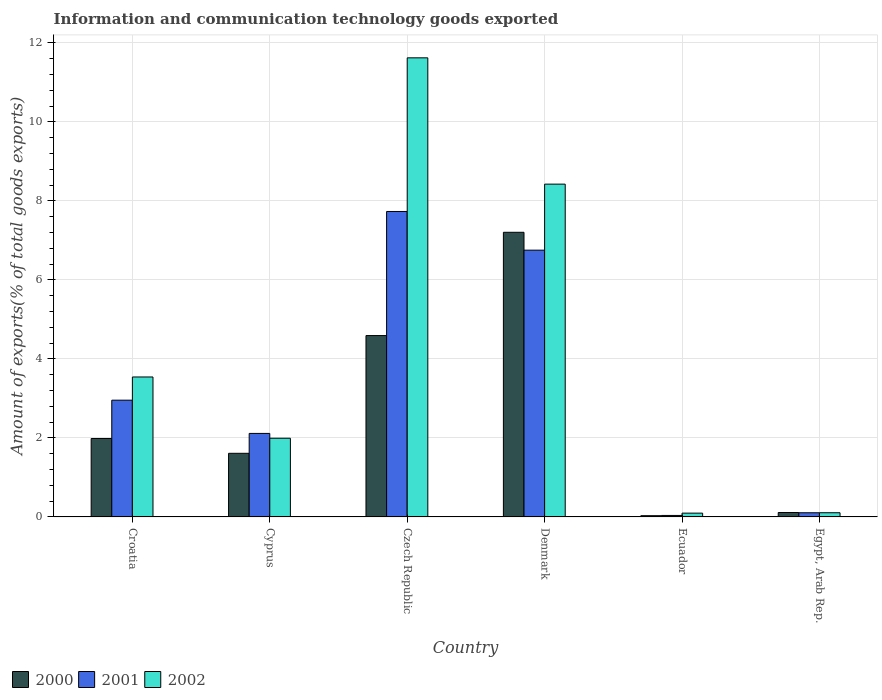How many groups of bars are there?
Offer a terse response. 6. How many bars are there on the 4th tick from the left?
Give a very brief answer. 3. What is the label of the 3rd group of bars from the left?
Ensure brevity in your answer.  Czech Republic. In how many cases, is the number of bars for a given country not equal to the number of legend labels?
Your answer should be compact. 0. What is the amount of goods exported in 2001 in Czech Republic?
Provide a succinct answer. 7.73. Across all countries, what is the maximum amount of goods exported in 2001?
Offer a terse response. 7.73. Across all countries, what is the minimum amount of goods exported in 2000?
Your response must be concise. 0.03. In which country was the amount of goods exported in 2001 maximum?
Keep it short and to the point. Czech Republic. In which country was the amount of goods exported in 2001 minimum?
Your response must be concise. Ecuador. What is the total amount of goods exported in 2001 in the graph?
Provide a succinct answer. 19.7. What is the difference between the amount of goods exported in 2002 in Czech Republic and that in Denmark?
Your answer should be very brief. 3.2. What is the difference between the amount of goods exported in 2002 in Croatia and the amount of goods exported in 2001 in Egypt, Arab Rep.?
Keep it short and to the point. 3.44. What is the average amount of goods exported in 2000 per country?
Offer a terse response. 2.59. What is the difference between the amount of goods exported of/in 2001 and amount of goods exported of/in 2002 in Denmark?
Provide a succinct answer. -1.67. What is the ratio of the amount of goods exported in 2001 in Denmark to that in Egypt, Arab Rep.?
Make the answer very short. 63.88. What is the difference between the highest and the second highest amount of goods exported in 2000?
Provide a short and direct response. -2.61. What is the difference between the highest and the lowest amount of goods exported in 2002?
Provide a short and direct response. 11.53. What does the 2nd bar from the left in Czech Republic represents?
Offer a terse response. 2001. How many countries are there in the graph?
Offer a very short reply. 6. What is the difference between two consecutive major ticks on the Y-axis?
Offer a terse response. 2. Are the values on the major ticks of Y-axis written in scientific E-notation?
Give a very brief answer. No. Does the graph contain any zero values?
Keep it short and to the point. No. Does the graph contain grids?
Provide a short and direct response. Yes. Where does the legend appear in the graph?
Make the answer very short. Bottom left. What is the title of the graph?
Keep it short and to the point. Information and communication technology goods exported. Does "1981" appear as one of the legend labels in the graph?
Your response must be concise. No. What is the label or title of the Y-axis?
Offer a very short reply. Amount of exports(% of total goods exports). What is the Amount of exports(% of total goods exports) in 2000 in Croatia?
Keep it short and to the point. 1.99. What is the Amount of exports(% of total goods exports) of 2001 in Croatia?
Keep it short and to the point. 2.96. What is the Amount of exports(% of total goods exports) in 2002 in Croatia?
Provide a short and direct response. 3.54. What is the Amount of exports(% of total goods exports) in 2000 in Cyprus?
Your answer should be compact. 1.61. What is the Amount of exports(% of total goods exports) in 2001 in Cyprus?
Your response must be concise. 2.11. What is the Amount of exports(% of total goods exports) of 2002 in Cyprus?
Provide a short and direct response. 1.99. What is the Amount of exports(% of total goods exports) of 2000 in Czech Republic?
Offer a terse response. 4.59. What is the Amount of exports(% of total goods exports) of 2001 in Czech Republic?
Offer a terse response. 7.73. What is the Amount of exports(% of total goods exports) of 2002 in Czech Republic?
Your answer should be very brief. 11.62. What is the Amount of exports(% of total goods exports) of 2000 in Denmark?
Offer a very short reply. 7.21. What is the Amount of exports(% of total goods exports) in 2001 in Denmark?
Offer a very short reply. 6.75. What is the Amount of exports(% of total goods exports) of 2002 in Denmark?
Your answer should be compact. 8.43. What is the Amount of exports(% of total goods exports) of 2000 in Ecuador?
Provide a succinct answer. 0.03. What is the Amount of exports(% of total goods exports) of 2001 in Ecuador?
Your answer should be very brief. 0.04. What is the Amount of exports(% of total goods exports) in 2002 in Ecuador?
Keep it short and to the point. 0.1. What is the Amount of exports(% of total goods exports) in 2000 in Egypt, Arab Rep.?
Keep it short and to the point. 0.11. What is the Amount of exports(% of total goods exports) of 2001 in Egypt, Arab Rep.?
Keep it short and to the point. 0.11. What is the Amount of exports(% of total goods exports) in 2002 in Egypt, Arab Rep.?
Your answer should be compact. 0.11. Across all countries, what is the maximum Amount of exports(% of total goods exports) of 2000?
Ensure brevity in your answer.  7.21. Across all countries, what is the maximum Amount of exports(% of total goods exports) of 2001?
Give a very brief answer. 7.73. Across all countries, what is the maximum Amount of exports(% of total goods exports) of 2002?
Your answer should be compact. 11.62. Across all countries, what is the minimum Amount of exports(% of total goods exports) in 2000?
Provide a succinct answer. 0.03. Across all countries, what is the minimum Amount of exports(% of total goods exports) in 2001?
Keep it short and to the point. 0.04. Across all countries, what is the minimum Amount of exports(% of total goods exports) of 2002?
Your answer should be very brief. 0.1. What is the total Amount of exports(% of total goods exports) in 2000 in the graph?
Ensure brevity in your answer.  15.54. What is the total Amount of exports(% of total goods exports) in 2001 in the graph?
Offer a very short reply. 19.7. What is the total Amount of exports(% of total goods exports) in 2002 in the graph?
Your response must be concise. 25.79. What is the difference between the Amount of exports(% of total goods exports) in 2000 in Croatia and that in Cyprus?
Offer a terse response. 0.38. What is the difference between the Amount of exports(% of total goods exports) of 2001 in Croatia and that in Cyprus?
Provide a short and direct response. 0.84. What is the difference between the Amount of exports(% of total goods exports) of 2002 in Croatia and that in Cyprus?
Give a very brief answer. 1.55. What is the difference between the Amount of exports(% of total goods exports) of 2000 in Croatia and that in Czech Republic?
Your answer should be very brief. -2.61. What is the difference between the Amount of exports(% of total goods exports) of 2001 in Croatia and that in Czech Republic?
Keep it short and to the point. -4.78. What is the difference between the Amount of exports(% of total goods exports) of 2002 in Croatia and that in Czech Republic?
Provide a succinct answer. -8.08. What is the difference between the Amount of exports(% of total goods exports) of 2000 in Croatia and that in Denmark?
Your answer should be very brief. -5.22. What is the difference between the Amount of exports(% of total goods exports) in 2001 in Croatia and that in Denmark?
Your answer should be very brief. -3.8. What is the difference between the Amount of exports(% of total goods exports) in 2002 in Croatia and that in Denmark?
Ensure brevity in your answer.  -4.88. What is the difference between the Amount of exports(% of total goods exports) of 2000 in Croatia and that in Ecuador?
Provide a short and direct response. 1.95. What is the difference between the Amount of exports(% of total goods exports) in 2001 in Croatia and that in Ecuador?
Make the answer very short. 2.92. What is the difference between the Amount of exports(% of total goods exports) in 2002 in Croatia and that in Ecuador?
Your response must be concise. 3.45. What is the difference between the Amount of exports(% of total goods exports) in 2000 in Croatia and that in Egypt, Arab Rep.?
Give a very brief answer. 1.87. What is the difference between the Amount of exports(% of total goods exports) of 2001 in Croatia and that in Egypt, Arab Rep.?
Offer a very short reply. 2.85. What is the difference between the Amount of exports(% of total goods exports) of 2002 in Croatia and that in Egypt, Arab Rep.?
Offer a terse response. 3.44. What is the difference between the Amount of exports(% of total goods exports) of 2000 in Cyprus and that in Czech Republic?
Keep it short and to the point. -2.98. What is the difference between the Amount of exports(% of total goods exports) of 2001 in Cyprus and that in Czech Republic?
Give a very brief answer. -5.62. What is the difference between the Amount of exports(% of total goods exports) in 2002 in Cyprus and that in Czech Republic?
Provide a short and direct response. -9.63. What is the difference between the Amount of exports(% of total goods exports) of 2000 in Cyprus and that in Denmark?
Make the answer very short. -5.6. What is the difference between the Amount of exports(% of total goods exports) of 2001 in Cyprus and that in Denmark?
Make the answer very short. -4.64. What is the difference between the Amount of exports(% of total goods exports) in 2002 in Cyprus and that in Denmark?
Provide a short and direct response. -6.43. What is the difference between the Amount of exports(% of total goods exports) of 2000 in Cyprus and that in Ecuador?
Your answer should be very brief. 1.58. What is the difference between the Amount of exports(% of total goods exports) of 2001 in Cyprus and that in Ecuador?
Your response must be concise. 2.08. What is the difference between the Amount of exports(% of total goods exports) of 2002 in Cyprus and that in Ecuador?
Ensure brevity in your answer.  1.9. What is the difference between the Amount of exports(% of total goods exports) in 2000 in Cyprus and that in Egypt, Arab Rep.?
Offer a terse response. 1.5. What is the difference between the Amount of exports(% of total goods exports) in 2001 in Cyprus and that in Egypt, Arab Rep.?
Your response must be concise. 2.01. What is the difference between the Amount of exports(% of total goods exports) in 2002 in Cyprus and that in Egypt, Arab Rep.?
Your answer should be compact. 1.89. What is the difference between the Amount of exports(% of total goods exports) of 2000 in Czech Republic and that in Denmark?
Ensure brevity in your answer.  -2.61. What is the difference between the Amount of exports(% of total goods exports) in 2001 in Czech Republic and that in Denmark?
Offer a terse response. 0.98. What is the difference between the Amount of exports(% of total goods exports) of 2002 in Czech Republic and that in Denmark?
Ensure brevity in your answer.  3.2. What is the difference between the Amount of exports(% of total goods exports) of 2000 in Czech Republic and that in Ecuador?
Your answer should be compact. 4.56. What is the difference between the Amount of exports(% of total goods exports) of 2001 in Czech Republic and that in Ecuador?
Ensure brevity in your answer.  7.7. What is the difference between the Amount of exports(% of total goods exports) in 2002 in Czech Republic and that in Ecuador?
Provide a short and direct response. 11.53. What is the difference between the Amount of exports(% of total goods exports) of 2000 in Czech Republic and that in Egypt, Arab Rep.?
Provide a succinct answer. 4.48. What is the difference between the Amount of exports(% of total goods exports) of 2001 in Czech Republic and that in Egypt, Arab Rep.?
Provide a short and direct response. 7.63. What is the difference between the Amount of exports(% of total goods exports) of 2002 in Czech Republic and that in Egypt, Arab Rep.?
Give a very brief answer. 11.52. What is the difference between the Amount of exports(% of total goods exports) in 2000 in Denmark and that in Ecuador?
Offer a terse response. 7.18. What is the difference between the Amount of exports(% of total goods exports) in 2001 in Denmark and that in Ecuador?
Give a very brief answer. 6.72. What is the difference between the Amount of exports(% of total goods exports) in 2002 in Denmark and that in Ecuador?
Make the answer very short. 8.33. What is the difference between the Amount of exports(% of total goods exports) in 2000 in Denmark and that in Egypt, Arab Rep.?
Your answer should be very brief. 7.09. What is the difference between the Amount of exports(% of total goods exports) in 2001 in Denmark and that in Egypt, Arab Rep.?
Keep it short and to the point. 6.65. What is the difference between the Amount of exports(% of total goods exports) of 2002 in Denmark and that in Egypt, Arab Rep.?
Ensure brevity in your answer.  8.32. What is the difference between the Amount of exports(% of total goods exports) in 2000 in Ecuador and that in Egypt, Arab Rep.?
Your answer should be compact. -0.08. What is the difference between the Amount of exports(% of total goods exports) of 2001 in Ecuador and that in Egypt, Arab Rep.?
Provide a succinct answer. -0.07. What is the difference between the Amount of exports(% of total goods exports) in 2002 in Ecuador and that in Egypt, Arab Rep.?
Ensure brevity in your answer.  -0.01. What is the difference between the Amount of exports(% of total goods exports) in 2000 in Croatia and the Amount of exports(% of total goods exports) in 2001 in Cyprus?
Provide a succinct answer. -0.13. What is the difference between the Amount of exports(% of total goods exports) of 2000 in Croatia and the Amount of exports(% of total goods exports) of 2002 in Cyprus?
Provide a succinct answer. -0.01. What is the difference between the Amount of exports(% of total goods exports) of 2001 in Croatia and the Amount of exports(% of total goods exports) of 2002 in Cyprus?
Offer a terse response. 0.96. What is the difference between the Amount of exports(% of total goods exports) in 2000 in Croatia and the Amount of exports(% of total goods exports) in 2001 in Czech Republic?
Your answer should be compact. -5.75. What is the difference between the Amount of exports(% of total goods exports) of 2000 in Croatia and the Amount of exports(% of total goods exports) of 2002 in Czech Republic?
Your response must be concise. -9.64. What is the difference between the Amount of exports(% of total goods exports) of 2001 in Croatia and the Amount of exports(% of total goods exports) of 2002 in Czech Republic?
Your answer should be compact. -8.67. What is the difference between the Amount of exports(% of total goods exports) of 2000 in Croatia and the Amount of exports(% of total goods exports) of 2001 in Denmark?
Offer a very short reply. -4.77. What is the difference between the Amount of exports(% of total goods exports) of 2000 in Croatia and the Amount of exports(% of total goods exports) of 2002 in Denmark?
Provide a succinct answer. -6.44. What is the difference between the Amount of exports(% of total goods exports) in 2001 in Croatia and the Amount of exports(% of total goods exports) in 2002 in Denmark?
Provide a succinct answer. -5.47. What is the difference between the Amount of exports(% of total goods exports) of 2000 in Croatia and the Amount of exports(% of total goods exports) of 2001 in Ecuador?
Provide a succinct answer. 1.95. What is the difference between the Amount of exports(% of total goods exports) in 2000 in Croatia and the Amount of exports(% of total goods exports) in 2002 in Ecuador?
Make the answer very short. 1.89. What is the difference between the Amount of exports(% of total goods exports) in 2001 in Croatia and the Amount of exports(% of total goods exports) in 2002 in Ecuador?
Provide a succinct answer. 2.86. What is the difference between the Amount of exports(% of total goods exports) of 2000 in Croatia and the Amount of exports(% of total goods exports) of 2001 in Egypt, Arab Rep.?
Ensure brevity in your answer.  1.88. What is the difference between the Amount of exports(% of total goods exports) of 2000 in Croatia and the Amount of exports(% of total goods exports) of 2002 in Egypt, Arab Rep.?
Ensure brevity in your answer.  1.88. What is the difference between the Amount of exports(% of total goods exports) of 2001 in Croatia and the Amount of exports(% of total goods exports) of 2002 in Egypt, Arab Rep.?
Your response must be concise. 2.85. What is the difference between the Amount of exports(% of total goods exports) of 2000 in Cyprus and the Amount of exports(% of total goods exports) of 2001 in Czech Republic?
Offer a very short reply. -6.12. What is the difference between the Amount of exports(% of total goods exports) of 2000 in Cyprus and the Amount of exports(% of total goods exports) of 2002 in Czech Republic?
Ensure brevity in your answer.  -10.01. What is the difference between the Amount of exports(% of total goods exports) of 2001 in Cyprus and the Amount of exports(% of total goods exports) of 2002 in Czech Republic?
Offer a very short reply. -9.51. What is the difference between the Amount of exports(% of total goods exports) of 2000 in Cyprus and the Amount of exports(% of total goods exports) of 2001 in Denmark?
Provide a succinct answer. -5.14. What is the difference between the Amount of exports(% of total goods exports) of 2000 in Cyprus and the Amount of exports(% of total goods exports) of 2002 in Denmark?
Provide a succinct answer. -6.81. What is the difference between the Amount of exports(% of total goods exports) of 2001 in Cyprus and the Amount of exports(% of total goods exports) of 2002 in Denmark?
Your answer should be very brief. -6.31. What is the difference between the Amount of exports(% of total goods exports) of 2000 in Cyprus and the Amount of exports(% of total goods exports) of 2001 in Ecuador?
Ensure brevity in your answer.  1.57. What is the difference between the Amount of exports(% of total goods exports) of 2000 in Cyprus and the Amount of exports(% of total goods exports) of 2002 in Ecuador?
Your response must be concise. 1.51. What is the difference between the Amount of exports(% of total goods exports) of 2001 in Cyprus and the Amount of exports(% of total goods exports) of 2002 in Ecuador?
Offer a terse response. 2.02. What is the difference between the Amount of exports(% of total goods exports) of 2000 in Cyprus and the Amount of exports(% of total goods exports) of 2001 in Egypt, Arab Rep.?
Provide a short and direct response. 1.51. What is the difference between the Amount of exports(% of total goods exports) of 2000 in Cyprus and the Amount of exports(% of total goods exports) of 2002 in Egypt, Arab Rep.?
Provide a short and direct response. 1.5. What is the difference between the Amount of exports(% of total goods exports) in 2001 in Cyprus and the Amount of exports(% of total goods exports) in 2002 in Egypt, Arab Rep.?
Your answer should be compact. 2.01. What is the difference between the Amount of exports(% of total goods exports) in 2000 in Czech Republic and the Amount of exports(% of total goods exports) in 2001 in Denmark?
Make the answer very short. -2.16. What is the difference between the Amount of exports(% of total goods exports) in 2000 in Czech Republic and the Amount of exports(% of total goods exports) in 2002 in Denmark?
Offer a very short reply. -3.83. What is the difference between the Amount of exports(% of total goods exports) of 2001 in Czech Republic and the Amount of exports(% of total goods exports) of 2002 in Denmark?
Keep it short and to the point. -0.69. What is the difference between the Amount of exports(% of total goods exports) of 2000 in Czech Republic and the Amount of exports(% of total goods exports) of 2001 in Ecuador?
Offer a very short reply. 4.55. What is the difference between the Amount of exports(% of total goods exports) of 2000 in Czech Republic and the Amount of exports(% of total goods exports) of 2002 in Ecuador?
Give a very brief answer. 4.5. What is the difference between the Amount of exports(% of total goods exports) of 2001 in Czech Republic and the Amount of exports(% of total goods exports) of 2002 in Ecuador?
Ensure brevity in your answer.  7.64. What is the difference between the Amount of exports(% of total goods exports) of 2000 in Czech Republic and the Amount of exports(% of total goods exports) of 2001 in Egypt, Arab Rep.?
Give a very brief answer. 4.49. What is the difference between the Amount of exports(% of total goods exports) in 2000 in Czech Republic and the Amount of exports(% of total goods exports) in 2002 in Egypt, Arab Rep.?
Make the answer very short. 4.49. What is the difference between the Amount of exports(% of total goods exports) of 2001 in Czech Republic and the Amount of exports(% of total goods exports) of 2002 in Egypt, Arab Rep.?
Keep it short and to the point. 7.63. What is the difference between the Amount of exports(% of total goods exports) of 2000 in Denmark and the Amount of exports(% of total goods exports) of 2001 in Ecuador?
Provide a short and direct response. 7.17. What is the difference between the Amount of exports(% of total goods exports) in 2000 in Denmark and the Amount of exports(% of total goods exports) in 2002 in Ecuador?
Your answer should be very brief. 7.11. What is the difference between the Amount of exports(% of total goods exports) of 2001 in Denmark and the Amount of exports(% of total goods exports) of 2002 in Ecuador?
Offer a terse response. 6.66. What is the difference between the Amount of exports(% of total goods exports) of 2000 in Denmark and the Amount of exports(% of total goods exports) of 2001 in Egypt, Arab Rep.?
Make the answer very short. 7.1. What is the difference between the Amount of exports(% of total goods exports) of 2000 in Denmark and the Amount of exports(% of total goods exports) of 2002 in Egypt, Arab Rep.?
Offer a very short reply. 7.1. What is the difference between the Amount of exports(% of total goods exports) of 2001 in Denmark and the Amount of exports(% of total goods exports) of 2002 in Egypt, Arab Rep.?
Provide a short and direct response. 6.65. What is the difference between the Amount of exports(% of total goods exports) of 2000 in Ecuador and the Amount of exports(% of total goods exports) of 2001 in Egypt, Arab Rep.?
Give a very brief answer. -0.07. What is the difference between the Amount of exports(% of total goods exports) of 2000 in Ecuador and the Amount of exports(% of total goods exports) of 2002 in Egypt, Arab Rep.?
Keep it short and to the point. -0.07. What is the difference between the Amount of exports(% of total goods exports) in 2001 in Ecuador and the Amount of exports(% of total goods exports) in 2002 in Egypt, Arab Rep.?
Your answer should be compact. -0.07. What is the average Amount of exports(% of total goods exports) of 2000 per country?
Your answer should be compact. 2.59. What is the average Amount of exports(% of total goods exports) of 2001 per country?
Make the answer very short. 3.28. What is the average Amount of exports(% of total goods exports) of 2002 per country?
Offer a terse response. 4.3. What is the difference between the Amount of exports(% of total goods exports) in 2000 and Amount of exports(% of total goods exports) in 2001 in Croatia?
Give a very brief answer. -0.97. What is the difference between the Amount of exports(% of total goods exports) in 2000 and Amount of exports(% of total goods exports) in 2002 in Croatia?
Offer a very short reply. -1.56. What is the difference between the Amount of exports(% of total goods exports) of 2001 and Amount of exports(% of total goods exports) of 2002 in Croatia?
Your answer should be compact. -0.59. What is the difference between the Amount of exports(% of total goods exports) of 2000 and Amount of exports(% of total goods exports) of 2001 in Cyprus?
Provide a succinct answer. -0.5. What is the difference between the Amount of exports(% of total goods exports) of 2000 and Amount of exports(% of total goods exports) of 2002 in Cyprus?
Your answer should be compact. -0.38. What is the difference between the Amount of exports(% of total goods exports) in 2001 and Amount of exports(% of total goods exports) in 2002 in Cyprus?
Your answer should be compact. 0.12. What is the difference between the Amount of exports(% of total goods exports) of 2000 and Amount of exports(% of total goods exports) of 2001 in Czech Republic?
Keep it short and to the point. -3.14. What is the difference between the Amount of exports(% of total goods exports) in 2000 and Amount of exports(% of total goods exports) in 2002 in Czech Republic?
Offer a terse response. -7.03. What is the difference between the Amount of exports(% of total goods exports) in 2001 and Amount of exports(% of total goods exports) in 2002 in Czech Republic?
Keep it short and to the point. -3.89. What is the difference between the Amount of exports(% of total goods exports) in 2000 and Amount of exports(% of total goods exports) in 2001 in Denmark?
Offer a very short reply. 0.45. What is the difference between the Amount of exports(% of total goods exports) in 2000 and Amount of exports(% of total goods exports) in 2002 in Denmark?
Your answer should be very brief. -1.22. What is the difference between the Amount of exports(% of total goods exports) of 2001 and Amount of exports(% of total goods exports) of 2002 in Denmark?
Offer a terse response. -1.67. What is the difference between the Amount of exports(% of total goods exports) of 2000 and Amount of exports(% of total goods exports) of 2001 in Ecuador?
Keep it short and to the point. -0.01. What is the difference between the Amount of exports(% of total goods exports) of 2000 and Amount of exports(% of total goods exports) of 2002 in Ecuador?
Offer a terse response. -0.06. What is the difference between the Amount of exports(% of total goods exports) in 2001 and Amount of exports(% of total goods exports) in 2002 in Ecuador?
Provide a short and direct response. -0.06. What is the difference between the Amount of exports(% of total goods exports) of 2000 and Amount of exports(% of total goods exports) of 2001 in Egypt, Arab Rep.?
Make the answer very short. 0.01. What is the difference between the Amount of exports(% of total goods exports) of 2000 and Amount of exports(% of total goods exports) of 2002 in Egypt, Arab Rep.?
Provide a short and direct response. 0.01. What is the difference between the Amount of exports(% of total goods exports) of 2001 and Amount of exports(% of total goods exports) of 2002 in Egypt, Arab Rep.?
Your response must be concise. -0. What is the ratio of the Amount of exports(% of total goods exports) of 2000 in Croatia to that in Cyprus?
Ensure brevity in your answer.  1.23. What is the ratio of the Amount of exports(% of total goods exports) in 2001 in Croatia to that in Cyprus?
Your answer should be compact. 1.4. What is the ratio of the Amount of exports(% of total goods exports) in 2002 in Croatia to that in Cyprus?
Your response must be concise. 1.78. What is the ratio of the Amount of exports(% of total goods exports) of 2000 in Croatia to that in Czech Republic?
Ensure brevity in your answer.  0.43. What is the ratio of the Amount of exports(% of total goods exports) in 2001 in Croatia to that in Czech Republic?
Your response must be concise. 0.38. What is the ratio of the Amount of exports(% of total goods exports) in 2002 in Croatia to that in Czech Republic?
Offer a very short reply. 0.3. What is the ratio of the Amount of exports(% of total goods exports) of 2000 in Croatia to that in Denmark?
Make the answer very short. 0.28. What is the ratio of the Amount of exports(% of total goods exports) in 2001 in Croatia to that in Denmark?
Your response must be concise. 0.44. What is the ratio of the Amount of exports(% of total goods exports) in 2002 in Croatia to that in Denmark?
Give a very brief answer. 0.42. What is the ratio of the Amount of exports(% of total goods exports) in 2000 in Croatia to that in Ecuador?
Provide a short and direct response. 63.48. What is the ratio of the Amount of exports(% of total goods exports) of 2001 in Croatia to that in Ecuador?
Provide a short and direct response. 78.7. What is the ratio of the Amount of exports(% of total goods exports) of 2002 in Croatia to that in Ecuador?
Provide a succinct answer. 36.9. What is the ratio of the Amount of exports(% of total goods exports) of 2000 in Croatia to that in Egypt, Arab Rep.?
Your response must be concise. 17.73. What is the ratio of the Amount of exports(% of total goods exports) of 2001 in Croatia to that in Egypt, Arab Rep.?
Your response must be concise. 27.96. What is the ratio of the Amount of exports(% of total goods exports) of 2002 in Croatia to that in Egypt, Arab Rep.?
Offer a terse response. 33.44. What is the ratio of the Amount of exports(% of total goods exports) in 2000 in Cyprus to that in Czech Republic?
Keep it short and to the point. 0.35. What is the ratio of the Amount of exports(% of total goods exports) of 2001 in Cyprus to that in Czech Republic?
Provide a succinct answer. 0.27. What is the ratio of the Amount of exports(% of total goods exports) in 2002 in Cyprus to that in Czech Republic?
Provide a succinct answer. 0.17. What is the ratio of the Amount of exports(% of total goods exports) in 2000 in Cyprus to that in Denmark?
Provide a short and direct response. 0.22. What is the ratio of the Amount of exports(% of total goods exports) of 2001 in Cyprus to that in Denmark?
Give a very brief answer. 0.31. What is the ratio of the Amount of exports(% of total goods exports) of 2002 in Cyprus to that in Denmark?
Your answer should be compact. 0.24. What is the ratio of the Amount of exports(% of total goods exports) of 2000 in Cyprus to that in Ecuador?
Provide a succinct answer. 51.49. What is the ratio of the Amount of exports(% of total goods exports) in 2001 in Cyprus to that in Ecuador?
Keep it short and to the point. 56.29. What is the ratio of the Amount of exports(% of total goods exports) in 2002 in Cyprus to that in Ecuador?
Make the answer very short. 20.75. What is the ratio of the Amount of exports(% of total goods exports) of 2000 in Cyprus to that in Egypt, Arab Rep.?
Offer a very short reply. 14.38. What is the ratio of the Amount of exports(% of total goods exports) in 2001 in Cyprus to that in Egypt, Arab Rep.?
Ensure brevity in your answer.  20. What is the ratio of the Amount of exports(% of total goods exports) in 2002 in Cyprus to that in Egypt, Arab Rep.?
Your answer should be very brief. 18.81. What is the ratio of the Amount of exports(% of total goods exports) in 2000 in Czech Republic to that in Denmark?
Your response must be concise. 0.64. What is the ratio of the Amount of exports(% of total goods exports) in 2001 in Czech Republic to that in Denmark?
Give a very brief answer. 1.15. What is the ratio of the Amount of exports(% of total goods exports) of 2002 in Czech Republic to that in Denmark?
Ensure brevity in your answer.  1.38. What is the ratio of the Amount of exports(% of total goods exports) in 2000 in Czech Republic to that in Ecuador?
Your answer should be compact. 146.76. What is the ratio of the Amount of exports(% of total goods exports) of 2001 in Czech Republic to that in Ecuador?
Offer a very short reply. 205.89. What is the ratio of the Amount of exports(% of total goods exports) of 2002 in Czech Republic to that in Ecuador?
Give a very brief answer. 121.03. What is the ratio of the Amount of exports(% of total goods exports) in 2000 in Czech Republic to that in Egypt, Arab Rep.?
Keep it short and to the point. 40.99. What is the ratio of the Amount of exports(% of total goods exports) of 2001 in Czech Republic to that in Egypt, Arab Rep.?
Ensure brevity in your answer.  73.14. What is the ratio of the Amount of exports(% of total goods exports) of 2002 in Czech Republic to that in Egypt, Arab Rep.?
Provide a short and direct response. 109.7. What is the ratio of the Amount of exports(% of total goods exports) in 2000 in Denmark to that in Ecuador?
Your answer should be very brief. 230.35. What is the ratio of the Amount of exports(% of total goods exports) of 2001 in Denmark to that in Ecuador?
Make the answer very short. 179.8. What is the ratio of the Amount of exports(% of total goods exports) of 2002 in Denmark to that in Ecuador?
Offer a terse response. 87.73. What is the ratio of the Amount of exports(% of total goods exports) of 2000 in Denmark to that in Egypt, Arab Rep.?
Give a very brief answer. 64.33. What is the ratio of the Amount of exports(% of total goods exports) of 2001 in Denmark to that in Egypt, Arab Rep.?
Offer a very short reply. 63.88. What is the ratio of the Amount of exports(% of total goods exports) in 2002 in Denmark to that in Egypt, Arab Rep.?
Keep it short and to the point. 79.52. What is the ratio of the Amount of exports(% of total goods exports) of 2000 in Ecuador to that in Egypt, Arab Rep.?
Make the answer very short. 0.28. What is the ratio of the Amount of exports(% of total goods exports) of 2001 in Ecuador to that in Egypt, Arab Rep.?
Offer a very short reply. 0.36. What is the ratio of the Amount of exports(% of total goods exports) in 2002 in Ecuador to that in Egypt, Arab Rep.?
Keep it short and to the point. 0.91. What is the difference between the highest and the second highest Amount of exports(% of total goods exports) in 2000?
Offer a very short reply. 2.61. What is the difference between the highest and the second highest Amount of exports(% of total goods exports) in 2001?
Provide a succinct answer. 0.98. What is the difference between the highest and the second highest Amount of exports(% of total goods exports) of 2002?
Give a very brief answer. 3.2. What is the difference between the highest and the lowest Amount of exports(% of total goods exports) of 2000?
Ensure brevity in your answer.  7.18. What is the difference between the highest and the lowest Amount of exports(% of total goods exports) of 2001?
Keep it short and to the point. 7.7. What is the difference between the highest and the lowest Amount of exports(% of total goods exports) in 2002?
Ensure brevity in your answer.  11.53. 